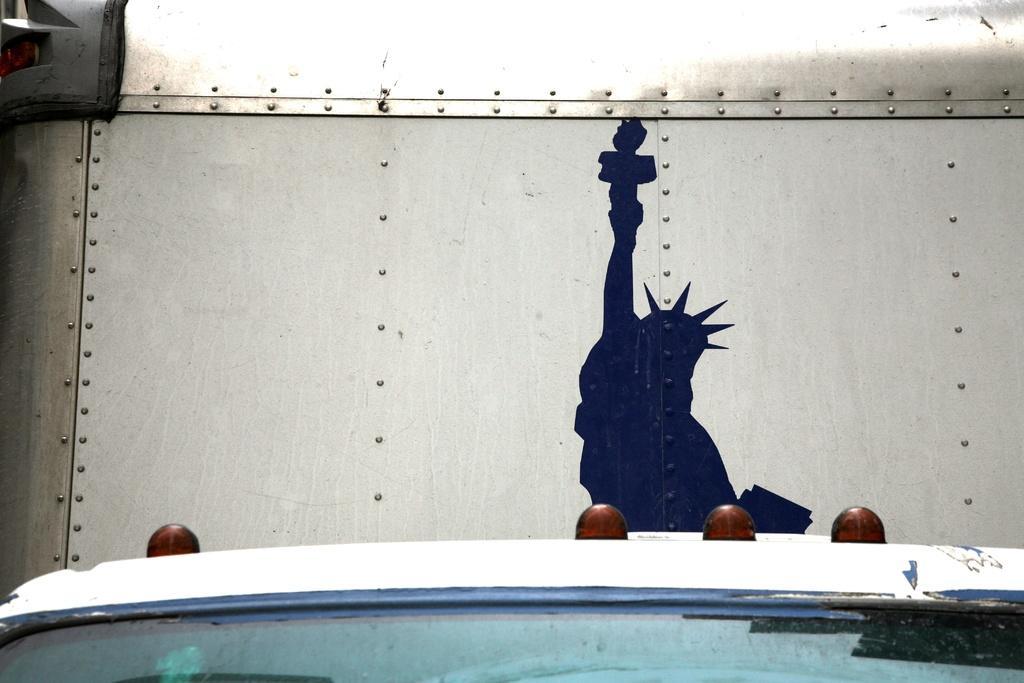In one or two sentences, can you explain what this image depicts? In this picture I see the statue of liberty in the black poster on the steel wall. At the bottom it might be a white car, behind that there are four bald heads. 